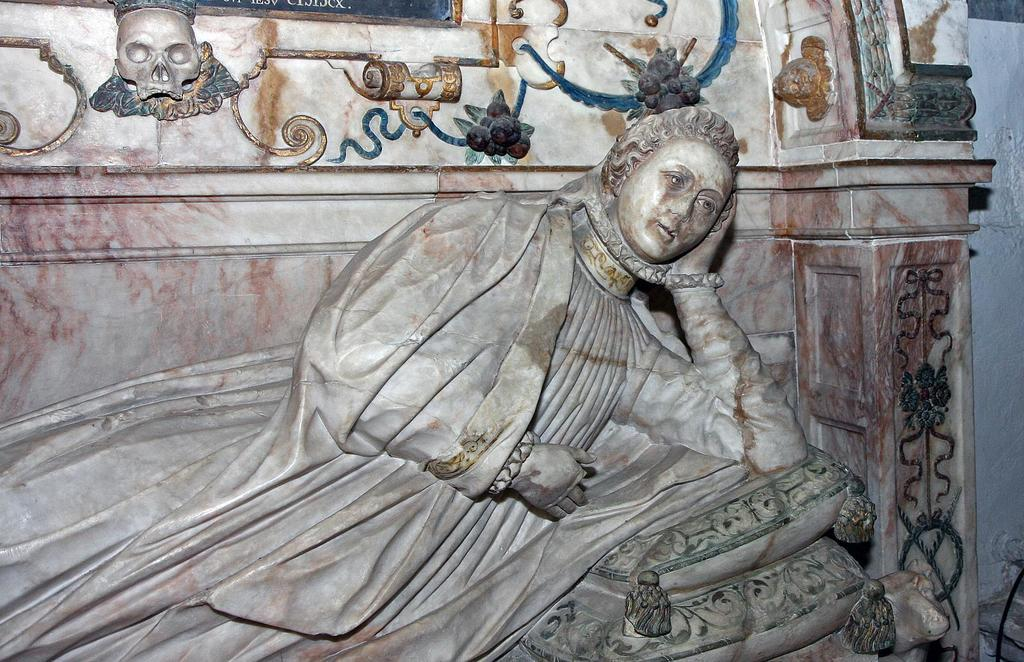What is the main subject of the image? There is a marble statue of a woman in the image. How is the statue positioned in the image? The statue is lying on the ground. What can be seen in the background of the image? There is a design on the marble stone in the background. What type of ornament is hanging from the statue's neck in the image? There is no ornament hanging from the statue's neck in the image; the statue is made of marble and does not have any additional adornments. 